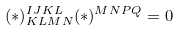<formula> <loc_0><loc_0><loc_500><loc_500>( * ) ^ { I J K L } _ { K L M N } ( * ) ^ { M N P Q } = 0</formula> 